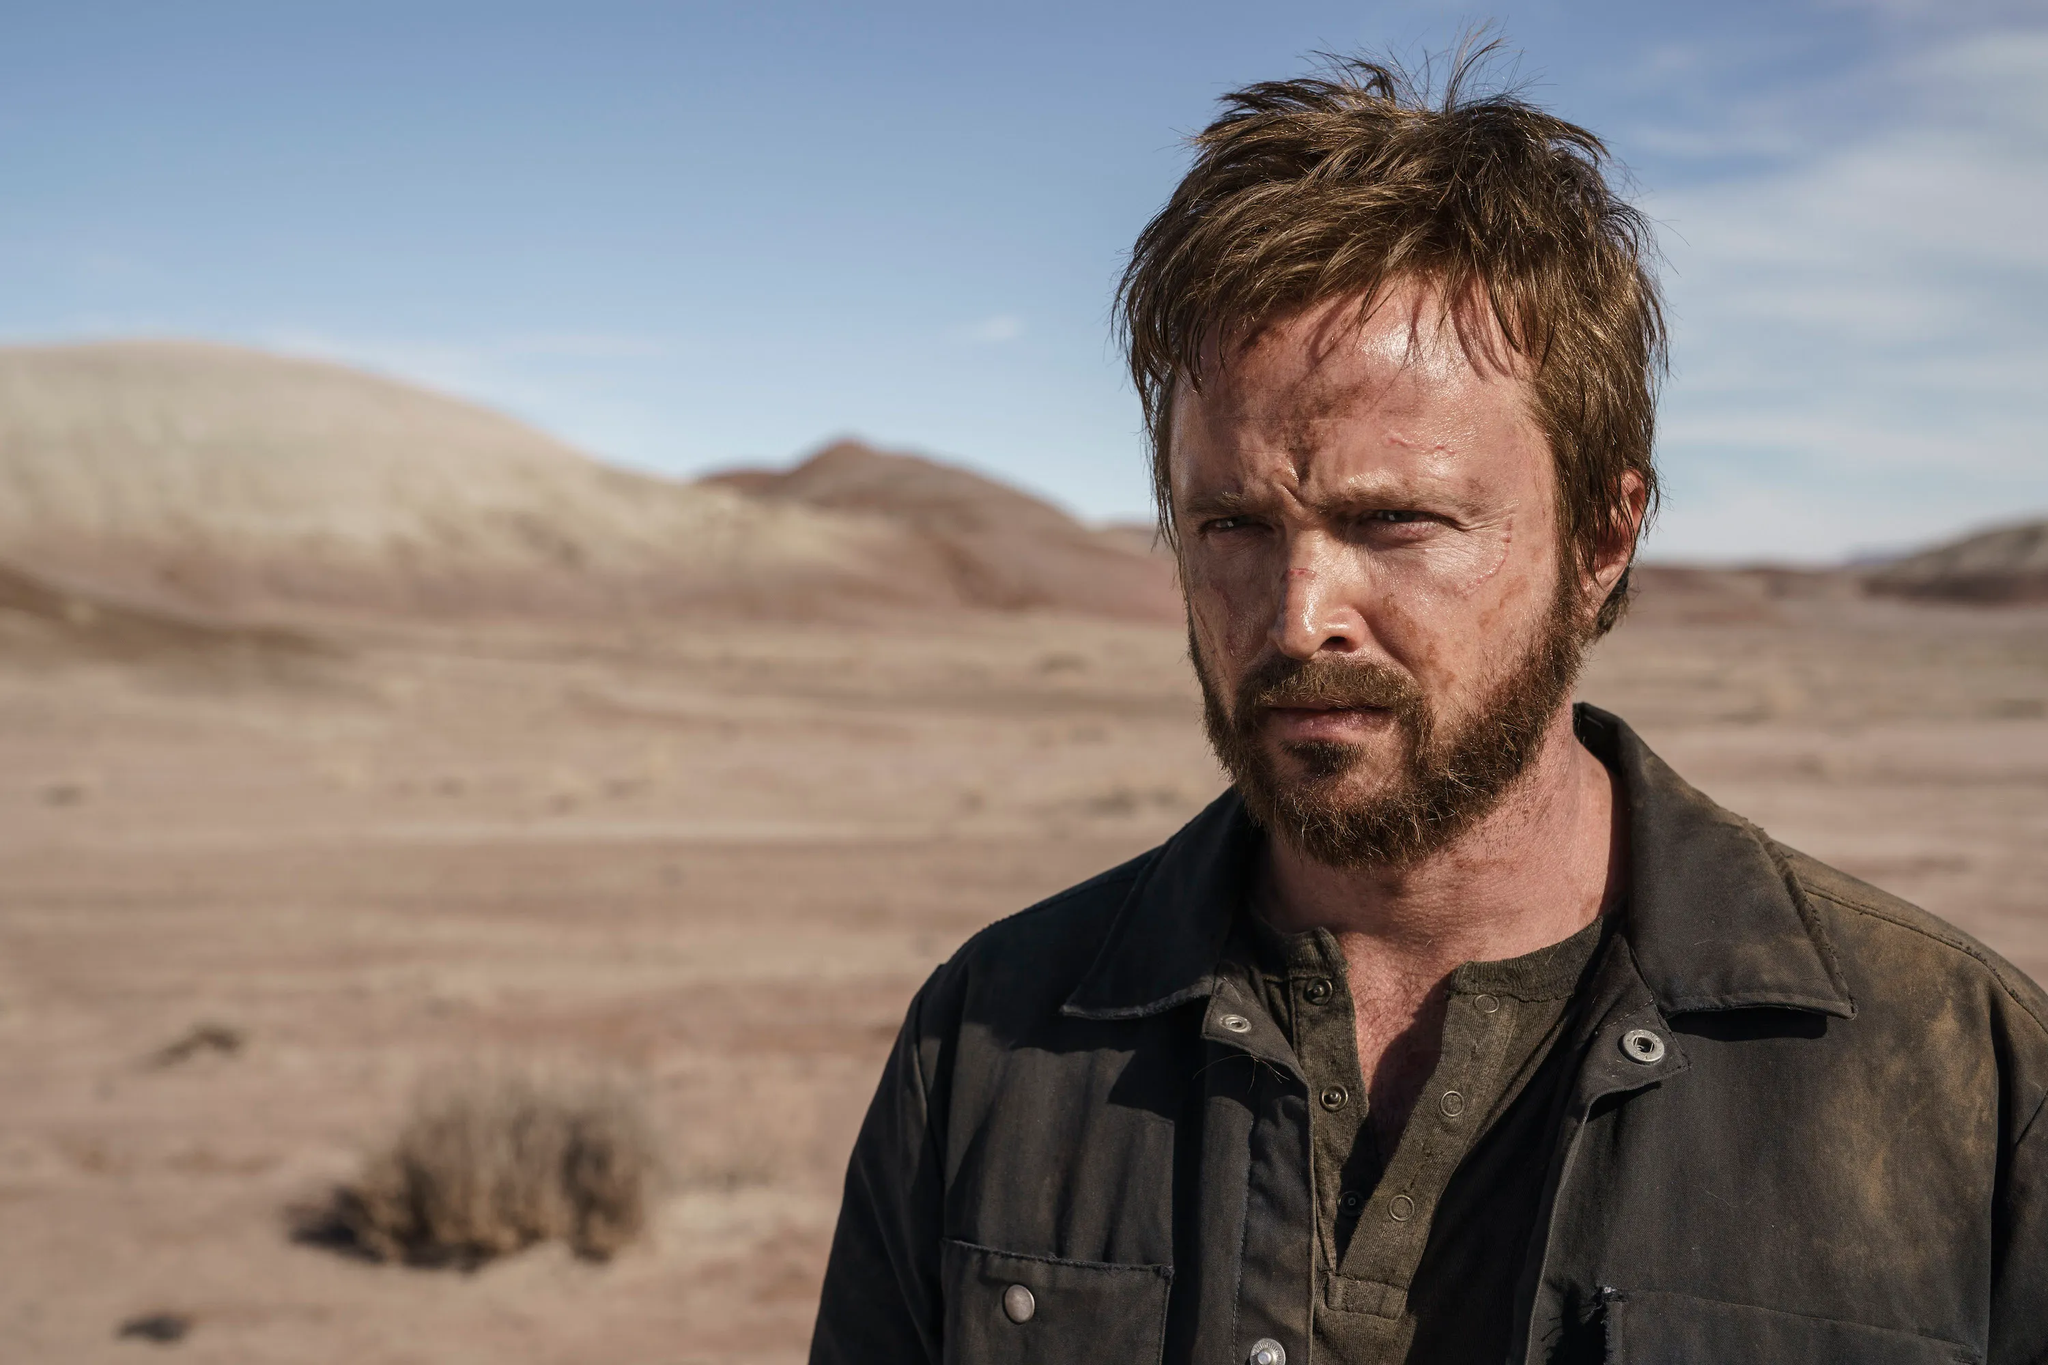What details can you tell me about the desert environment? The desert in the image has a sparse and open terrain with rolling hills in the distance. The soil appears to be dry and rocky, and there is very little vegetation, with just a few scattered shrubs. The mountains in the backdrop add to the arid scene, emphasizing the isolation of the landscape. The clear sky suggests a harsh sunlight that might contribute to the extreme temperature fluctuations typical of a desert environment. 